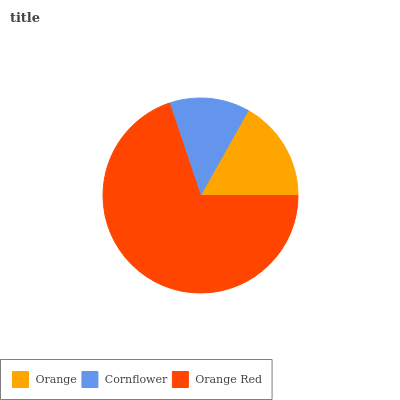Is Cornflower the minimum?
Answer yes or no. Yes. Is Orange Red the maximum?
Answer yes or no. Yes. Is Orange Red the minimum?
Answer yes or no. No. Is Cornflower the maximum?
Answer yes or no. No. Is Orange Red greater than Cornflower?
Answer yes or no. Yes. Is Cornflower less than Orange Red?
Answer yes or no. Yes. Is Cornflower greater than Orange Red?
Answer yes or no. No. Is Orange Red less than Cornflower?
Answer yes or no. No. Is Orange the high median?
Answer yes or no. Yes. Is Orange the low median?
Answer yes or no. Yes. Is Orange Red the high median?
Answer yes or no. No. Is Cornflower the low median?
Answer yes or no. No. 